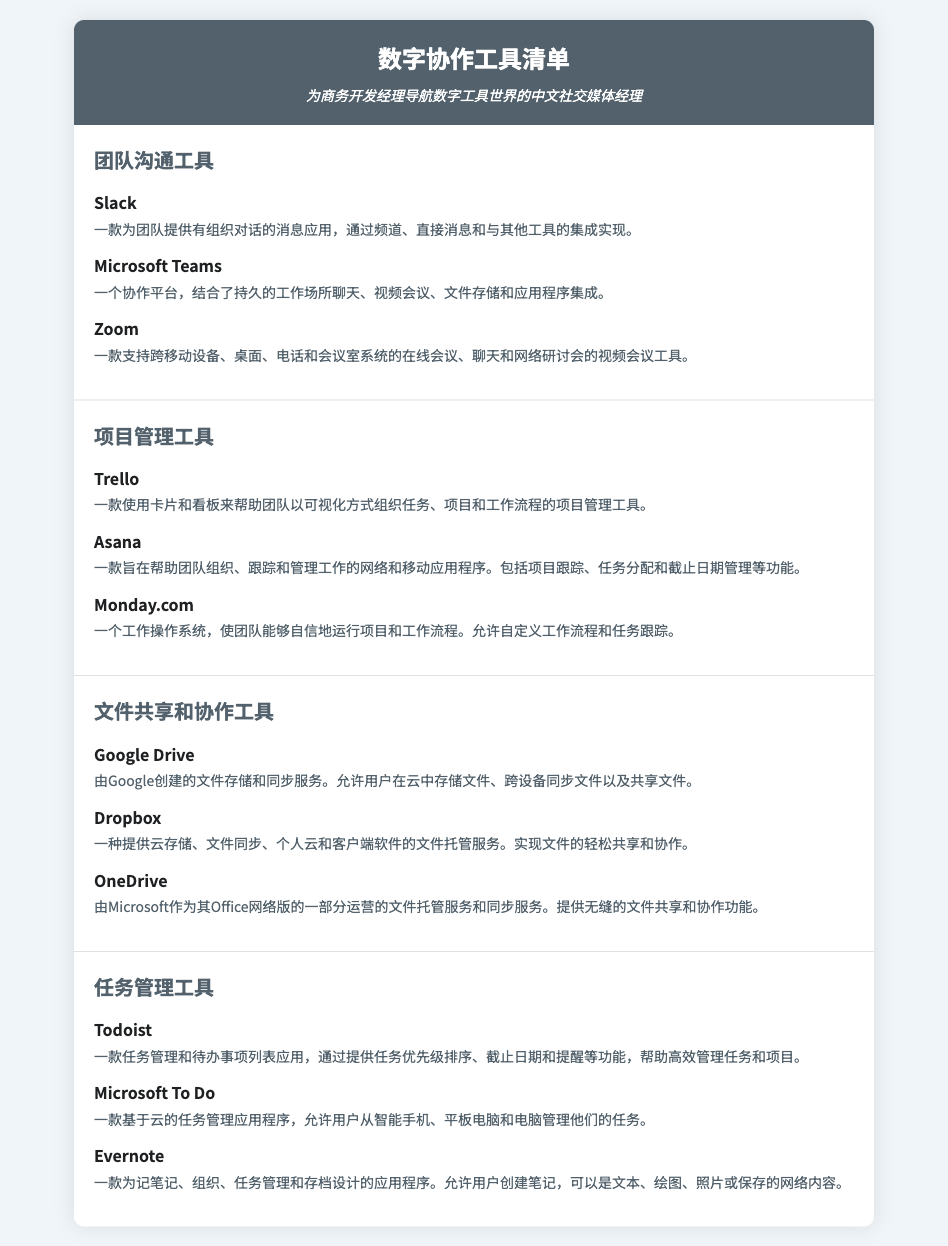什么是团队沟通工具的第一个条目？ 在文档中，团队沟通工具的第一个条目是Slack。
Answer: Slack Trello是用于什么目的的工具？ 在文档中，Trello被描述为用于帮助团队以可视化方式组织任务、项目和工作流程的项目管理工具。
Answer: 项目管理 Google Drive的提供者是谁？ 根据文档，Google Drive由Google创建。
Answer: Google 文档中列出了多少种任务管理工具？ 文档中列出了三种任务管理工具，包括Todoist、Microsoft To Do和Evernote。
Answer: 三种 Microsoft Teams结合了哪些功能？ 根据文档，Microsoft Teams结合了持久的工作场所聊天、视频会议、文件存储和应用程序集成。
Answer: 四种功能 